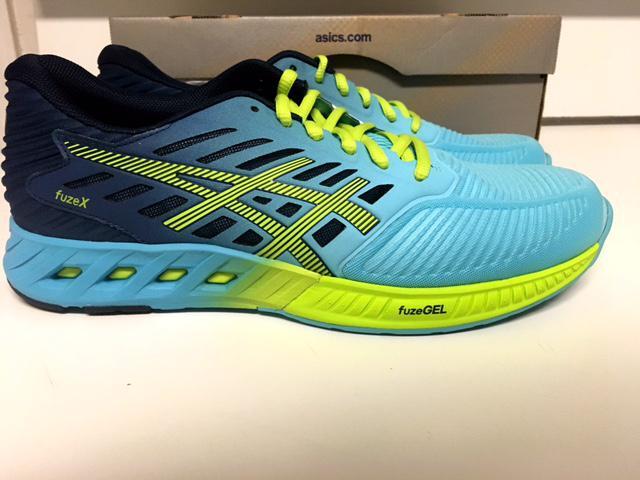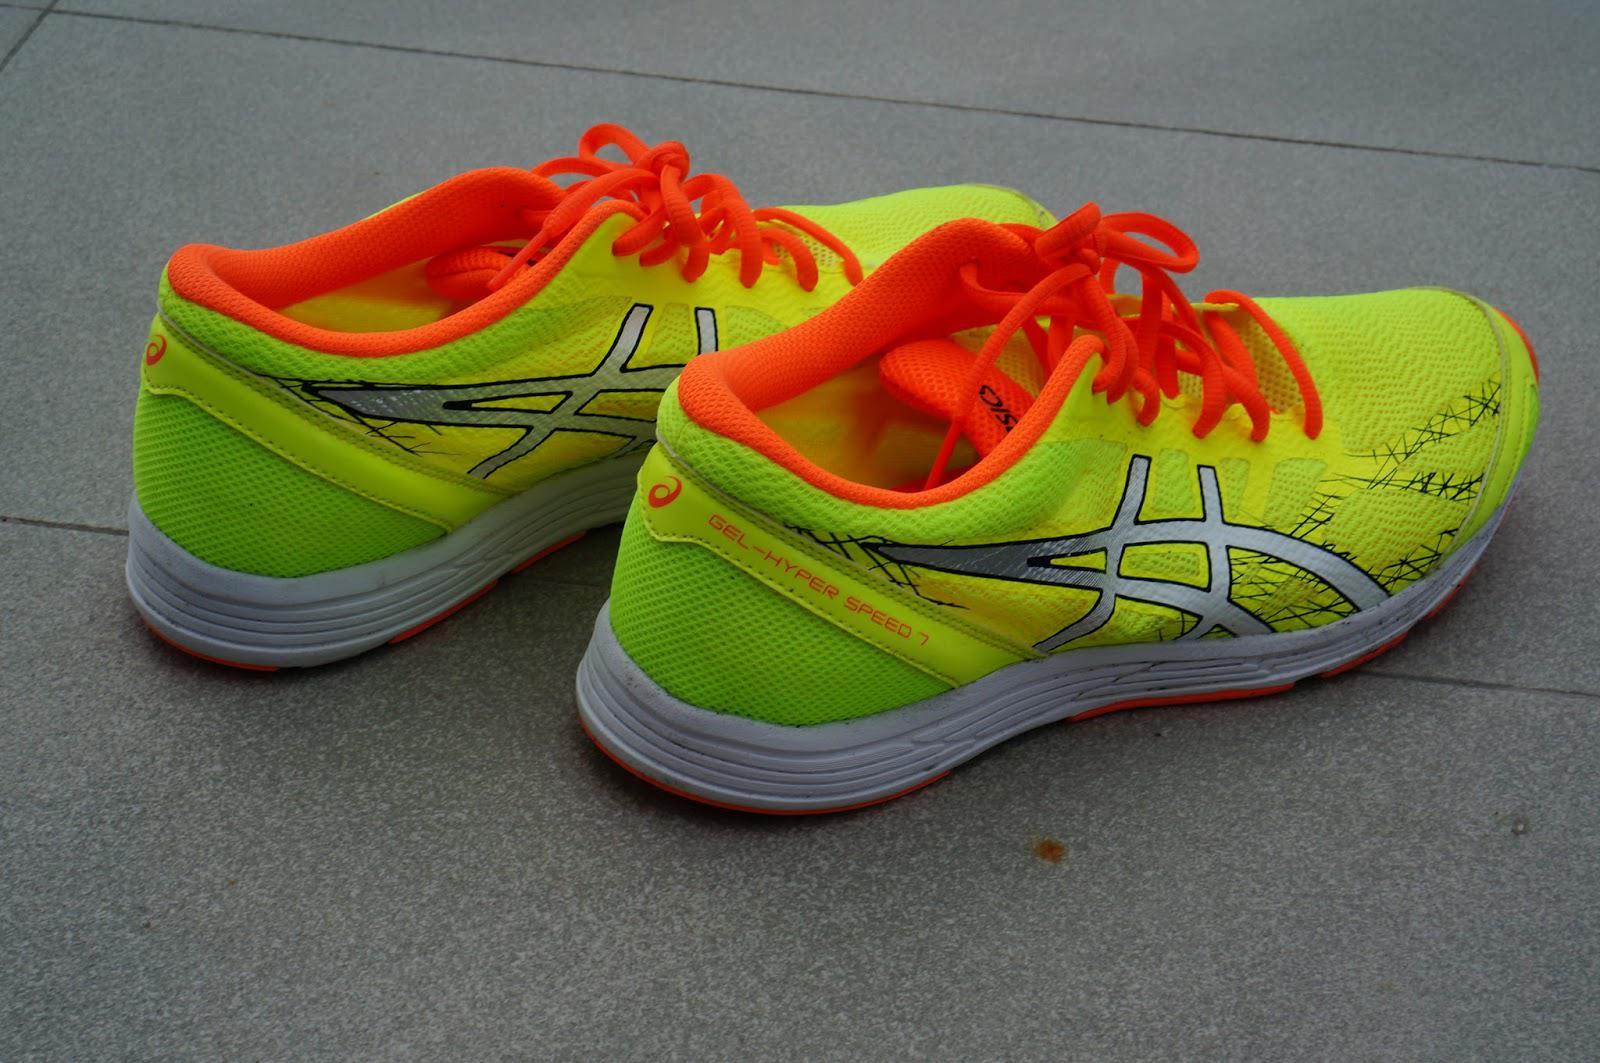The first image is the image on the left, the second image is the image on the right. Considering the images on both sides, is "A shoe is sitting on top of another object." valid? Answer yes or no. No. The first image is the image on the left, the second image is the image on the right. Analyze the images presented: Is the assertion "There are exactly two sneakers." valid? Answer yes or no. No. 